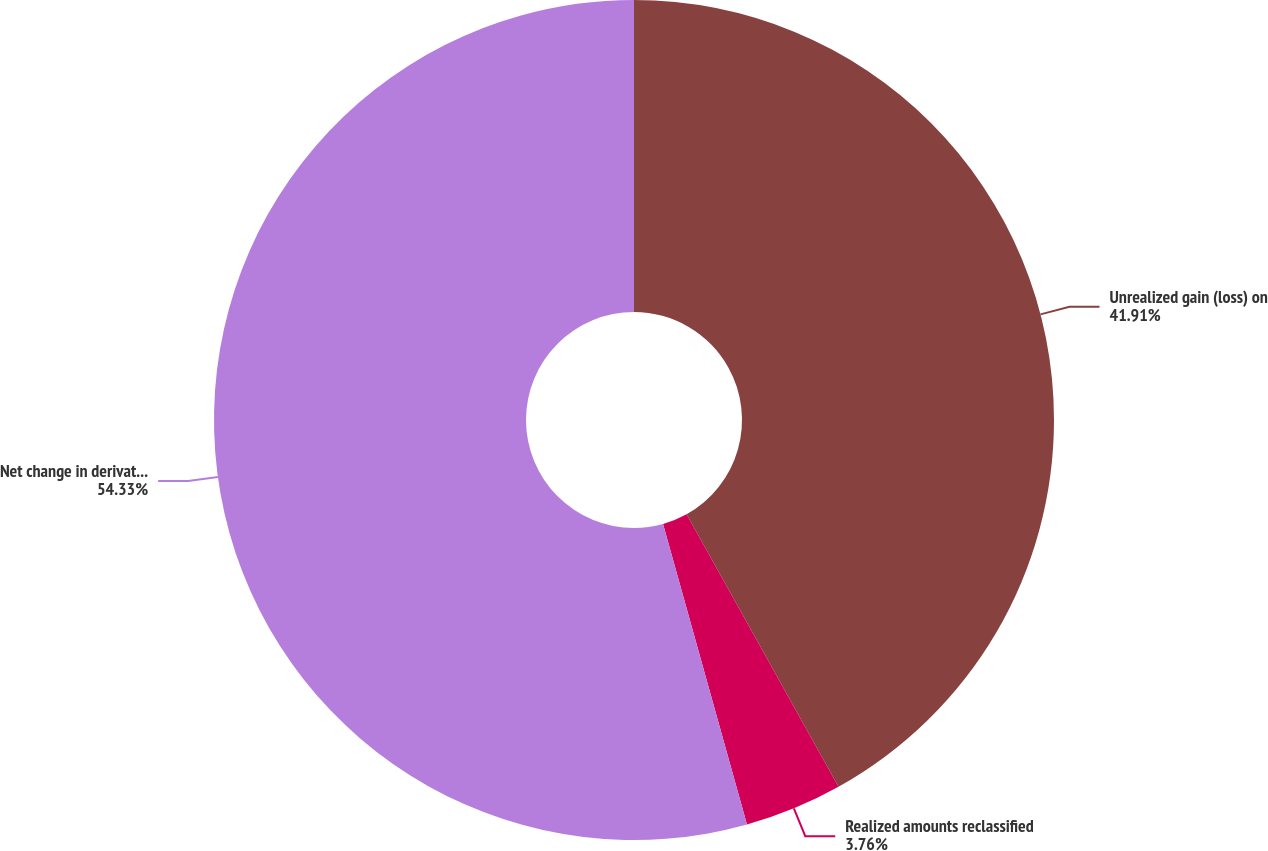Convert chart to OTSL. <chart><loc_0><loc_0><loc_500><loc_500><pie_chart><fcel>Unrealized gain (loss) on<fcel>Realized amounts reclassified<fcel>Net change in derivative fair<nl><fcel>41.91%<fcel>3.76%<fcel>54.34%<nl></chart> 